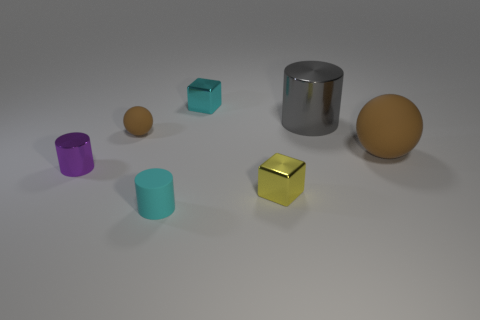Which object appears to be closest to the point of view, and can you infer anything about its size relative to the others? The closest object to the point of view is the small orange matte sphere in the foreground. While precise measurements are not possible from the image alone, it's apparent that it's smaller than the other spherical object and the cylinders. Its position and size relative to other objects give the scene depth and a sense of three-dimensional space. 